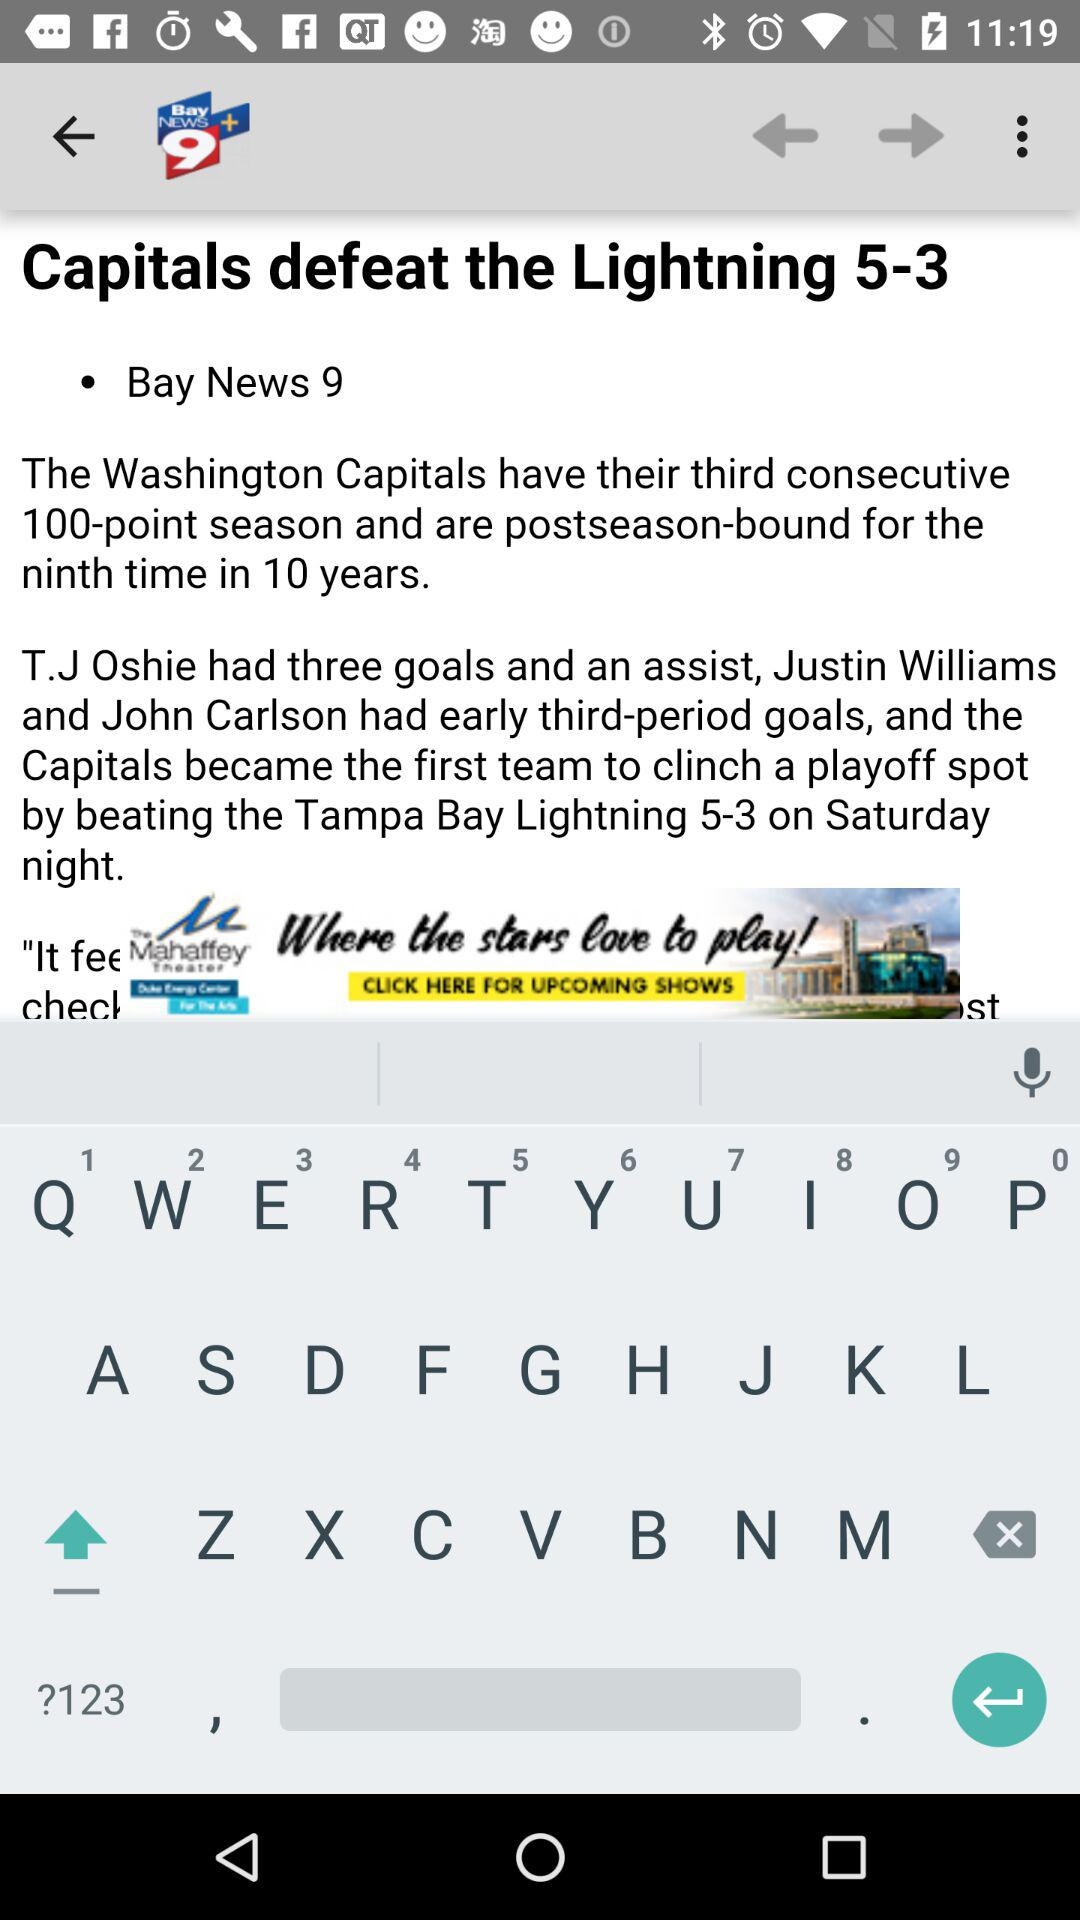What is the news channel name? The news channel name is "Bay News 9". 